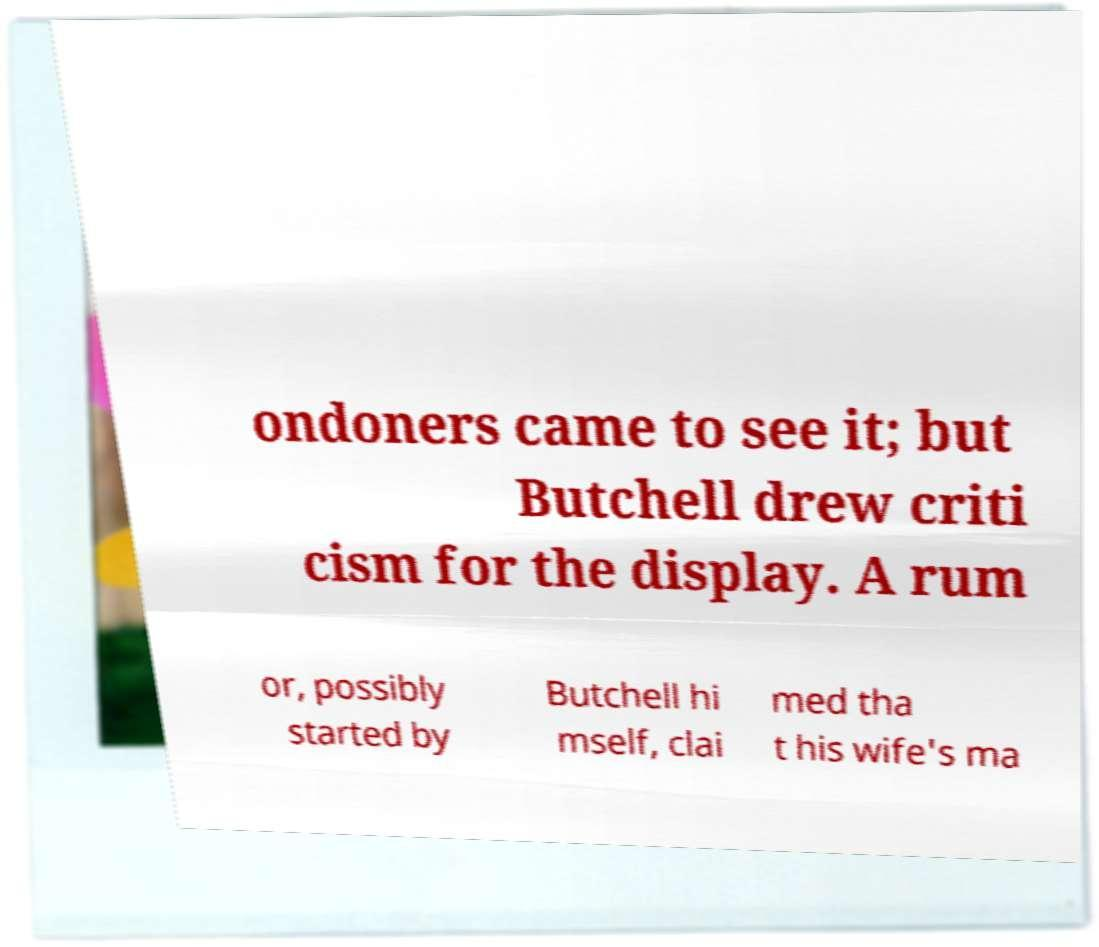Could you assist in decoding the text presented in this image and type it out clearly? ondoners came to see it; but Butchell drew criti cism for the display. A rum or, possibly started by Butchell hi mself, clai med tha t his wife's ma 